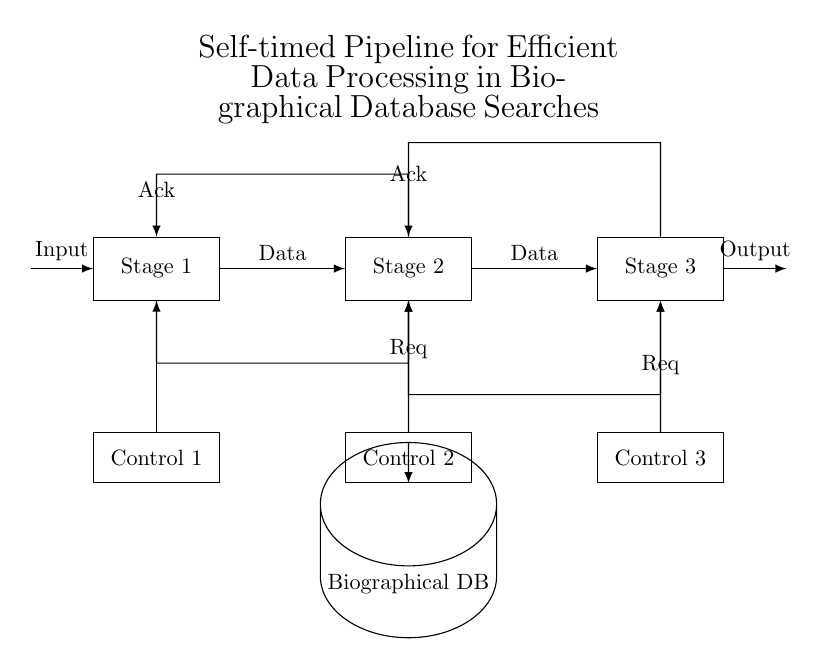What are the stages in the pipeline? The diagram clearly identifies three stages labeled as Stage 1, Stage 2, and Stage 3, suggesting these are the processing stages in the pipeline.
Answer: Stage 1, Stage 2, Stage 3 What is the role of the database in this circuit? The biographical database is depicted as a component below the stages, indicating that it provides data to Stage 2 through a control connection, facilitating data processing.
Answer: Biographical DB How many handshake signals are in the circuit? The diagram shows one handshake signal labeled as "Req" and one as "Ack" in connection between each sequential stage, leading to a total of four handshake signals.
Answer: Four Which control signal connects to Stage 2? The control connection is made from Control 2 to Stage 2 in the diagram, illustrating its role in managing Stage 2 operations.
Answer: Control 2 What does 'Ack' signify in the context of the circuit? The 'Ack' signals represent acknowledgments being sent back to the previous stage, confirming that the data has been received and processed, indicating a proper handshake mechanism in asynchronous systems.
Answer: Acknowledgment Which stage receives data from the input? Stage 1 is designated as the entry point for input data in the circuit diagram, clearly marked by an incoming arrow labeled "Input."
Answer: Stage 1 How are the stages connected for data flow? The stages are interconnected sequentially, with arrows indicating the flow of data from Stage 1 to Stage 2, and then to Stage 3, demonstrating a synchronous flow of processing.
Answer: Sequentially 